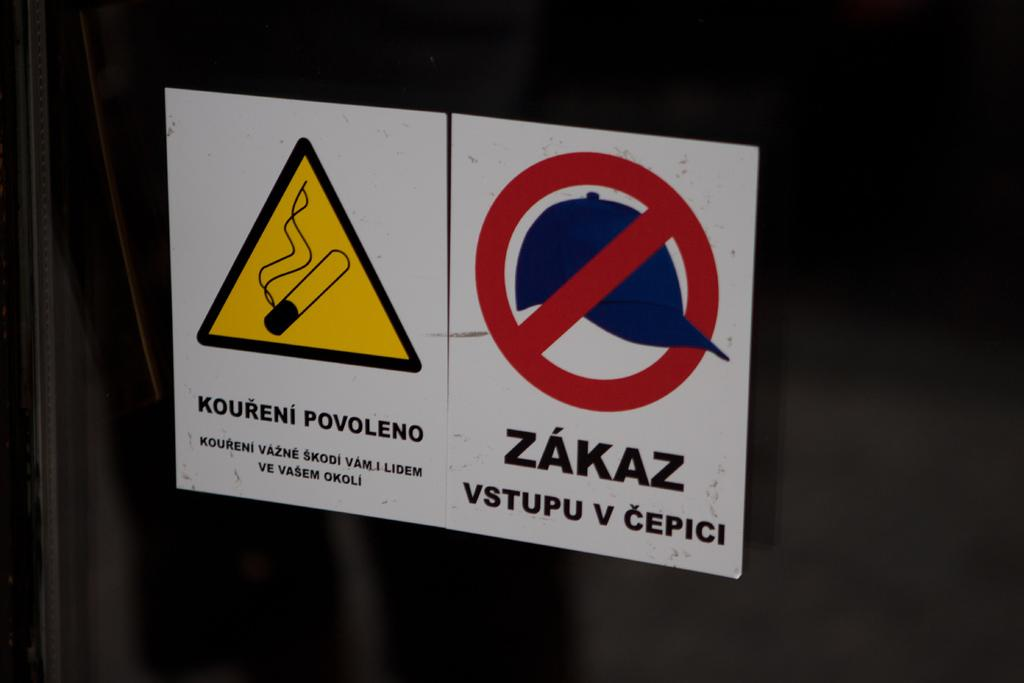<image>
Offer a succinct explanation of the picture presented. the word zakaz that is next to another sign 